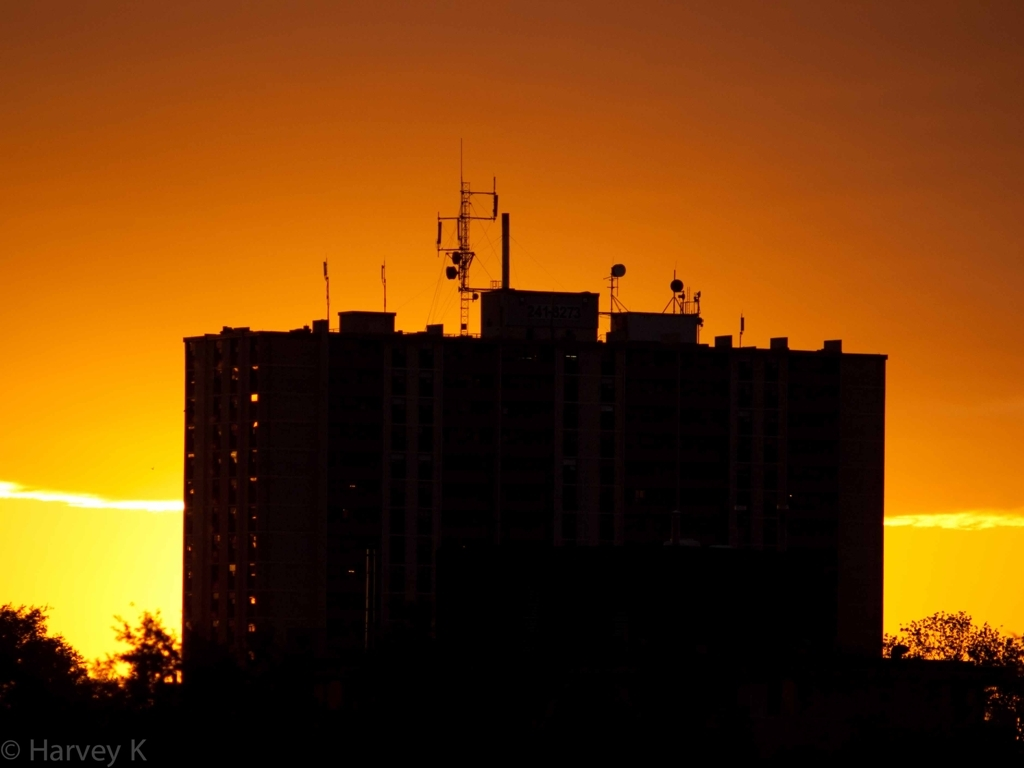Can you tell me more about the building's architecture? While details are obscured by the silhouette, the building appears to be a high-rise, possibly residential or commercial. It exhibits a functional architectural style, with a flat roof topped by various antennae, suggesting communications equipment or facilities. 